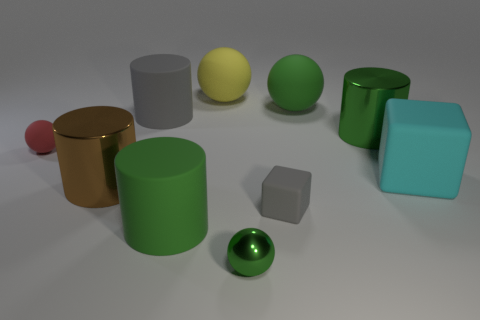Subtract all cylinders. How many objects are left? 6 Add 8 cyan rubber spheres. How many cyan rubber spheres exist? 8 Subtract 0 cyan balls. How many objects are left? 10 Subtract all gray cylinders. Subtract all big green rubber blocks. How many objects are left? 9 Add 1 big yellow spheres. How many big yellow spheres are left? 2 